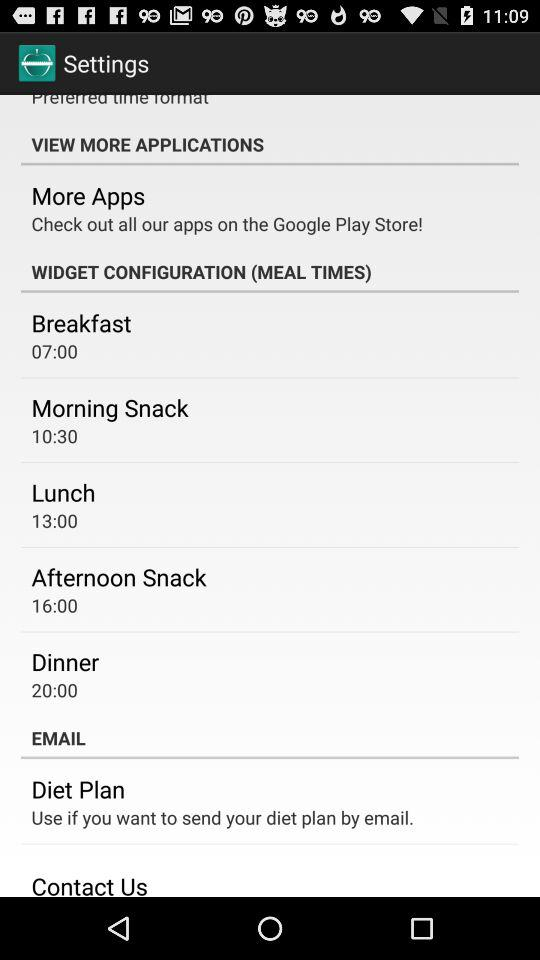What is the morning snack time? The morning snack time is 10:30. 